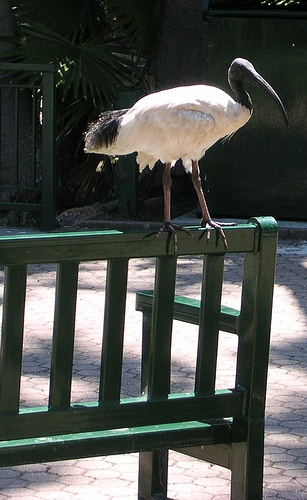Describe the objects in this image and their specific colors. I can see bench in black, white, gray, and darkgray tones and bird in black, darkgray, tan, and white tones in this image. 